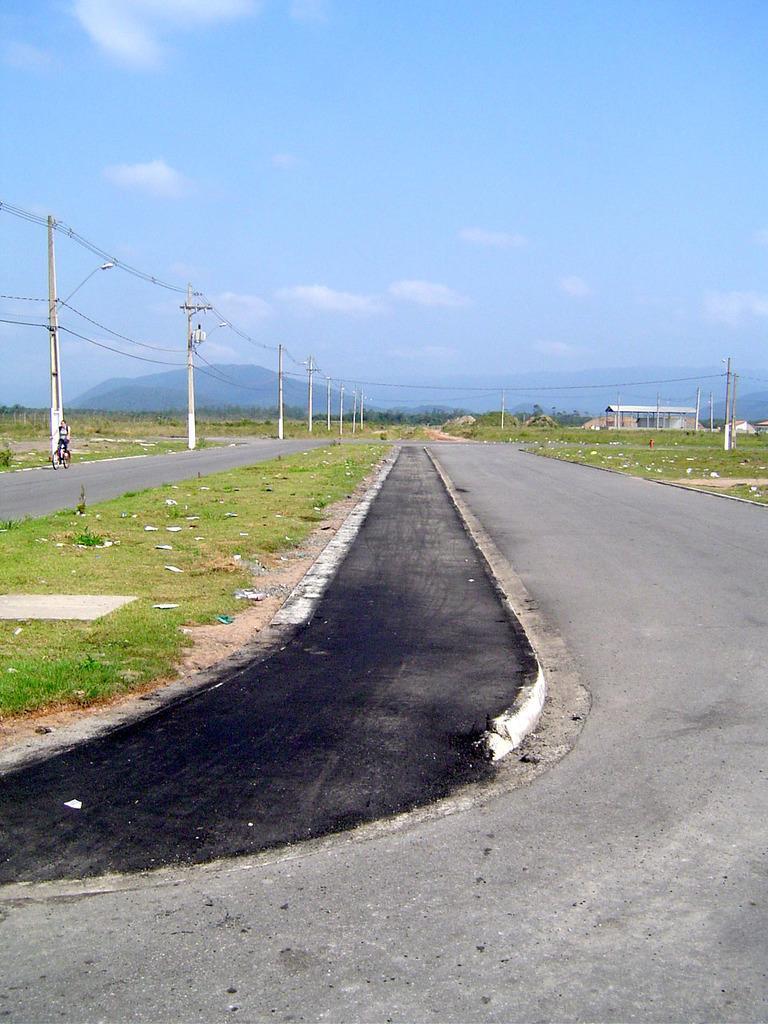Could you give a brief overview of what you see in this image? In the foreground of the picture there are road, grass. In the background there are current polls, cables, trees, grass, hills and rock. On the right there is a person riding a bicycle. Sky is clear. 